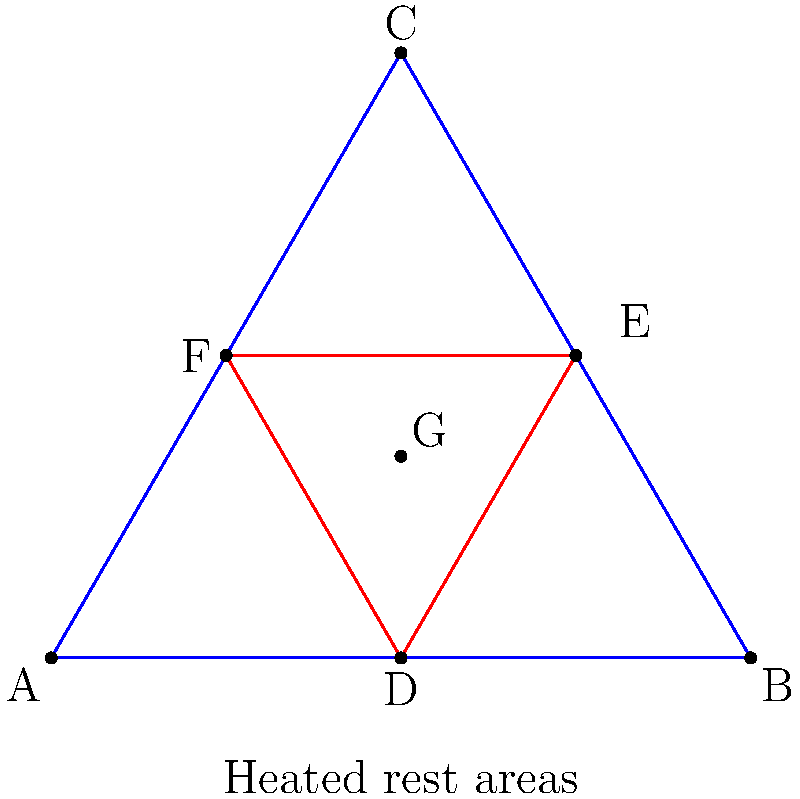In a large triangular construction site, heated worker rest areas are to be arranged symmetrically. The site is represented by triangle ABC, with rest areas placed at the midpoints D, E, and F of the sides. An additional central rest area G is located at the centroid of the triangle. How many rotational symmetries does this arrangement possess? To determine the number of rotational symmetries, we need to follow these steps:

1. Identify the shape formed by the rest areas:
   The rest areas D, E, and F form an equilateral triangle inscribed in the larger triangle ABC.

2. Consider the central point G:
   G is located at the centroid of both triangles ABC and DEF.

3. Analyze the rotational symmetries:
   a) A 120° rotation around G will map the arrangement onto itself.
   b) A 240° rotation around G will also map the arrangement onto itself.
   c) A 360° rotation (full turn) will return the arrangement to its original position.

4. Count the distinct rotations:
   We have three distinct rotations that preserve the arrangement: 120°, 240°, and 360° (which is equivalent to 0° or no rotation).

Therefore, the arrangement possesses 3 rotational symmetries.

This symmetric arrangement ensures equal accessibility to rest areas for workers across the construction site, which is particularly important in frigid Nordic weather conditions.
Answer: 3 